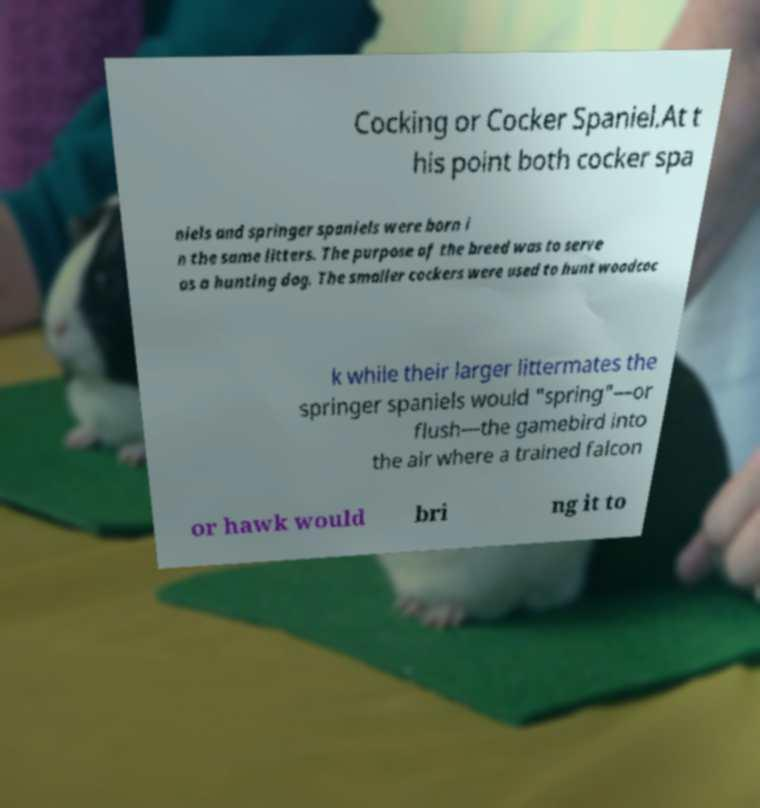There's text embedded in this image that I need extracted. Can you transcribe it verbatim? Cocking or Cocker Spaniel.At t his point both cocker spa niels and springer spaniels were born i n the same litters. The purpose of the breed was to serve as a hunting dog. The smaller cockers were used to hunt woodcoc k while their larger littermates the springer spaniels would "spring"—or flush—the gamebird into the air where a trained falcon or hawk would bri ng it to 